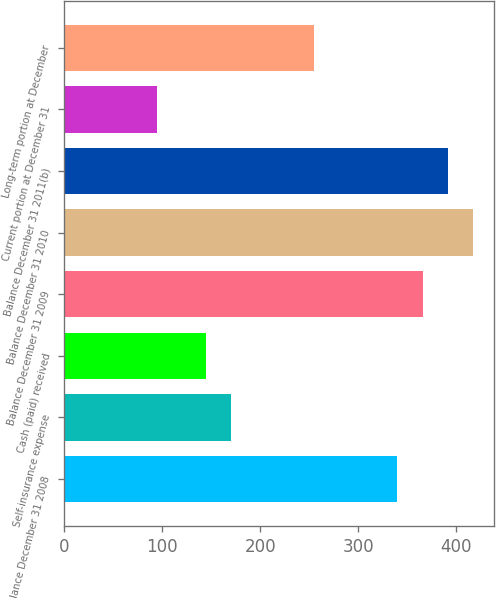Convert chart. <chart><loc_0><loc_0><loc_500><loc_500><bar_chart><fcel>Balance December 31 2008<fcel>Self-insurance expense<fcel>Cash (paid) received<fcel>Balance December 31 2009<fcel>Balance December 31 2010<fcel>Balance December 31 2011(b)<fcel>Current portion at December 31<fcel>Long-term portion at December<nl><fcel>340<fcel>170.8<fcel>145<fcel>365.8<fcel>417.4<fcel>391.6<fcel>95<fcel>255<nl></chart> 